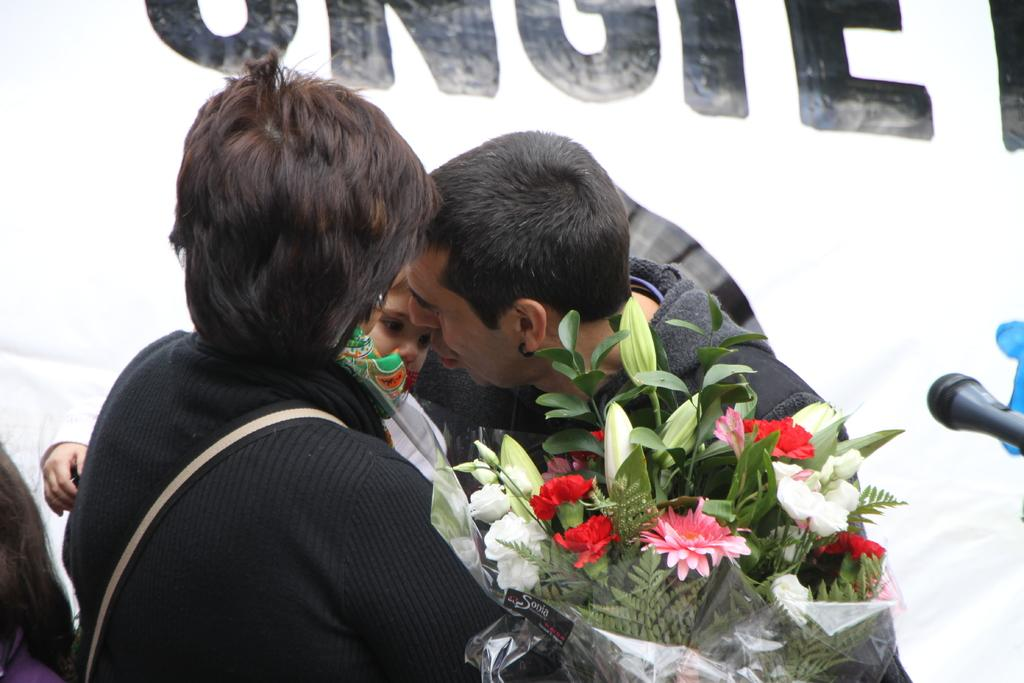What is located in the foreground of the picture? There is a group of people, a bouquet, flowers, and a mic in the foreground of the picture. What type of objects are present in the foreground of the picture? The foreground contains a bouquet, flowers, and a mic. What can be seen in the background of the picture? There is a banner in the background of the picture. Can you tell me how many nerves are visible in the picture? There are no nerves present in the picture; it features a group of people, a bouquet, flowers, a mic, and a banner. What type of rabbit can be seen in the picture? There is no rabbit present in the picture. 